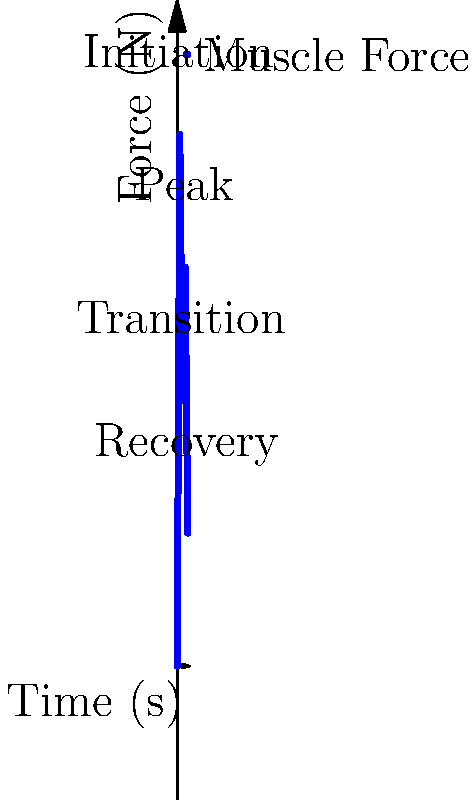In the African dance movement depicted by the muscle force vector graph, during which phase does the muscle exert the highest force, and what is the approximate magnitude of this force? To answer this question, we need to analyze the graph of muscle force vectors during different phases of the African dance movement. Let's break it down step-by-step:

1. Identify the phases of the dance movement:
   - Initiation (0-1 seconds)
   - Transition (1-2 seconds)
   - Peak (2-3 seconds)
   - Recovery (3-4 seconds)

2. Examine the force values for each phase:
   - Initiation: Force increases from 0 N to approximately 200 N
   - Transition: Force decreases from 200 N to about 100 N
   - Peak: Force increases from 100 N to around 150 N
   - Recovery: Force decreases from 150 N to about 50 N

3. Determine the highest force:
   The highest point on the graph occurs at the end of the Initiation phase, reaching approximately 200 N.

4. Identify the phase with the highest force:
   The Initiation phase (0-1 seconds) shows the steepest increase and reaches the highest point on the graph.

Therefore, the muscle exerts the highest force during the Initiation phase, with an approximate magnitude of 200 N.
Answer: Initiation phase, 200 N 